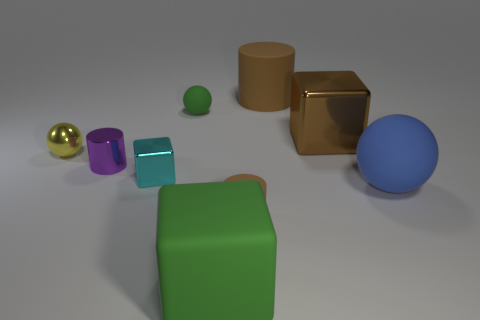Subtract all cyan metallic cubes. How many cubes are left? 2 Subtract 2 balls. How many balls are left? 1 Subtract all brown cylinders. How many cylinders are left? 1 Subtract all balls. How many objects are left? 6 Subtract all purple cylinders. Subtract all gray spheres. How many cylinders are left? 2 Subtract 1 brown cubes. How many objects are left? 8 Subtract all gray spheres. How many brown blocks are left? 1 Subtract all large things. Subtract all purple shiny objects. How many objects are left? 4 Add 2 blue objects. How many blue objects are left? 3 Add 4 red metal cubes. How many red metal cubes exist? 4 